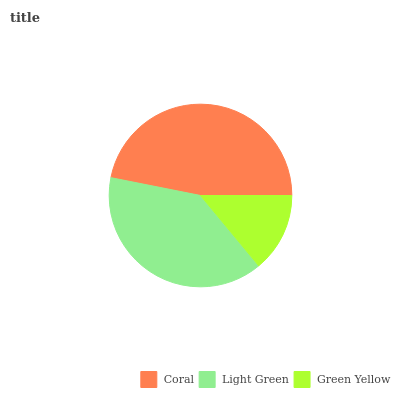Is Green Yellow the minimum?
Answer yes or no. Yes. Is Coral the maximum?
Answer yes or no. Yes. Is Light Green the minimum?
Answer yes or no. No. Is Light Green the maximum?
Answer yes or no. No. Is Coral greater than Light Green?
Answer yes or no. Yes. Is Light Green less than Coral?
Answer yes or no. Yes. Is Light Green greater than Coral?
Answer yes or no. No. Is Coral less than Light Green?
Answer yes or no. No. Is Light Green the high median?
Answer yes or no. Yes. Is Light Green the low median?
Answer yes or no. Yes. Is Green Yellow the high median?
Answer yes or no. No. Is Green Yellow the low median?
Answer yes or no. No. 